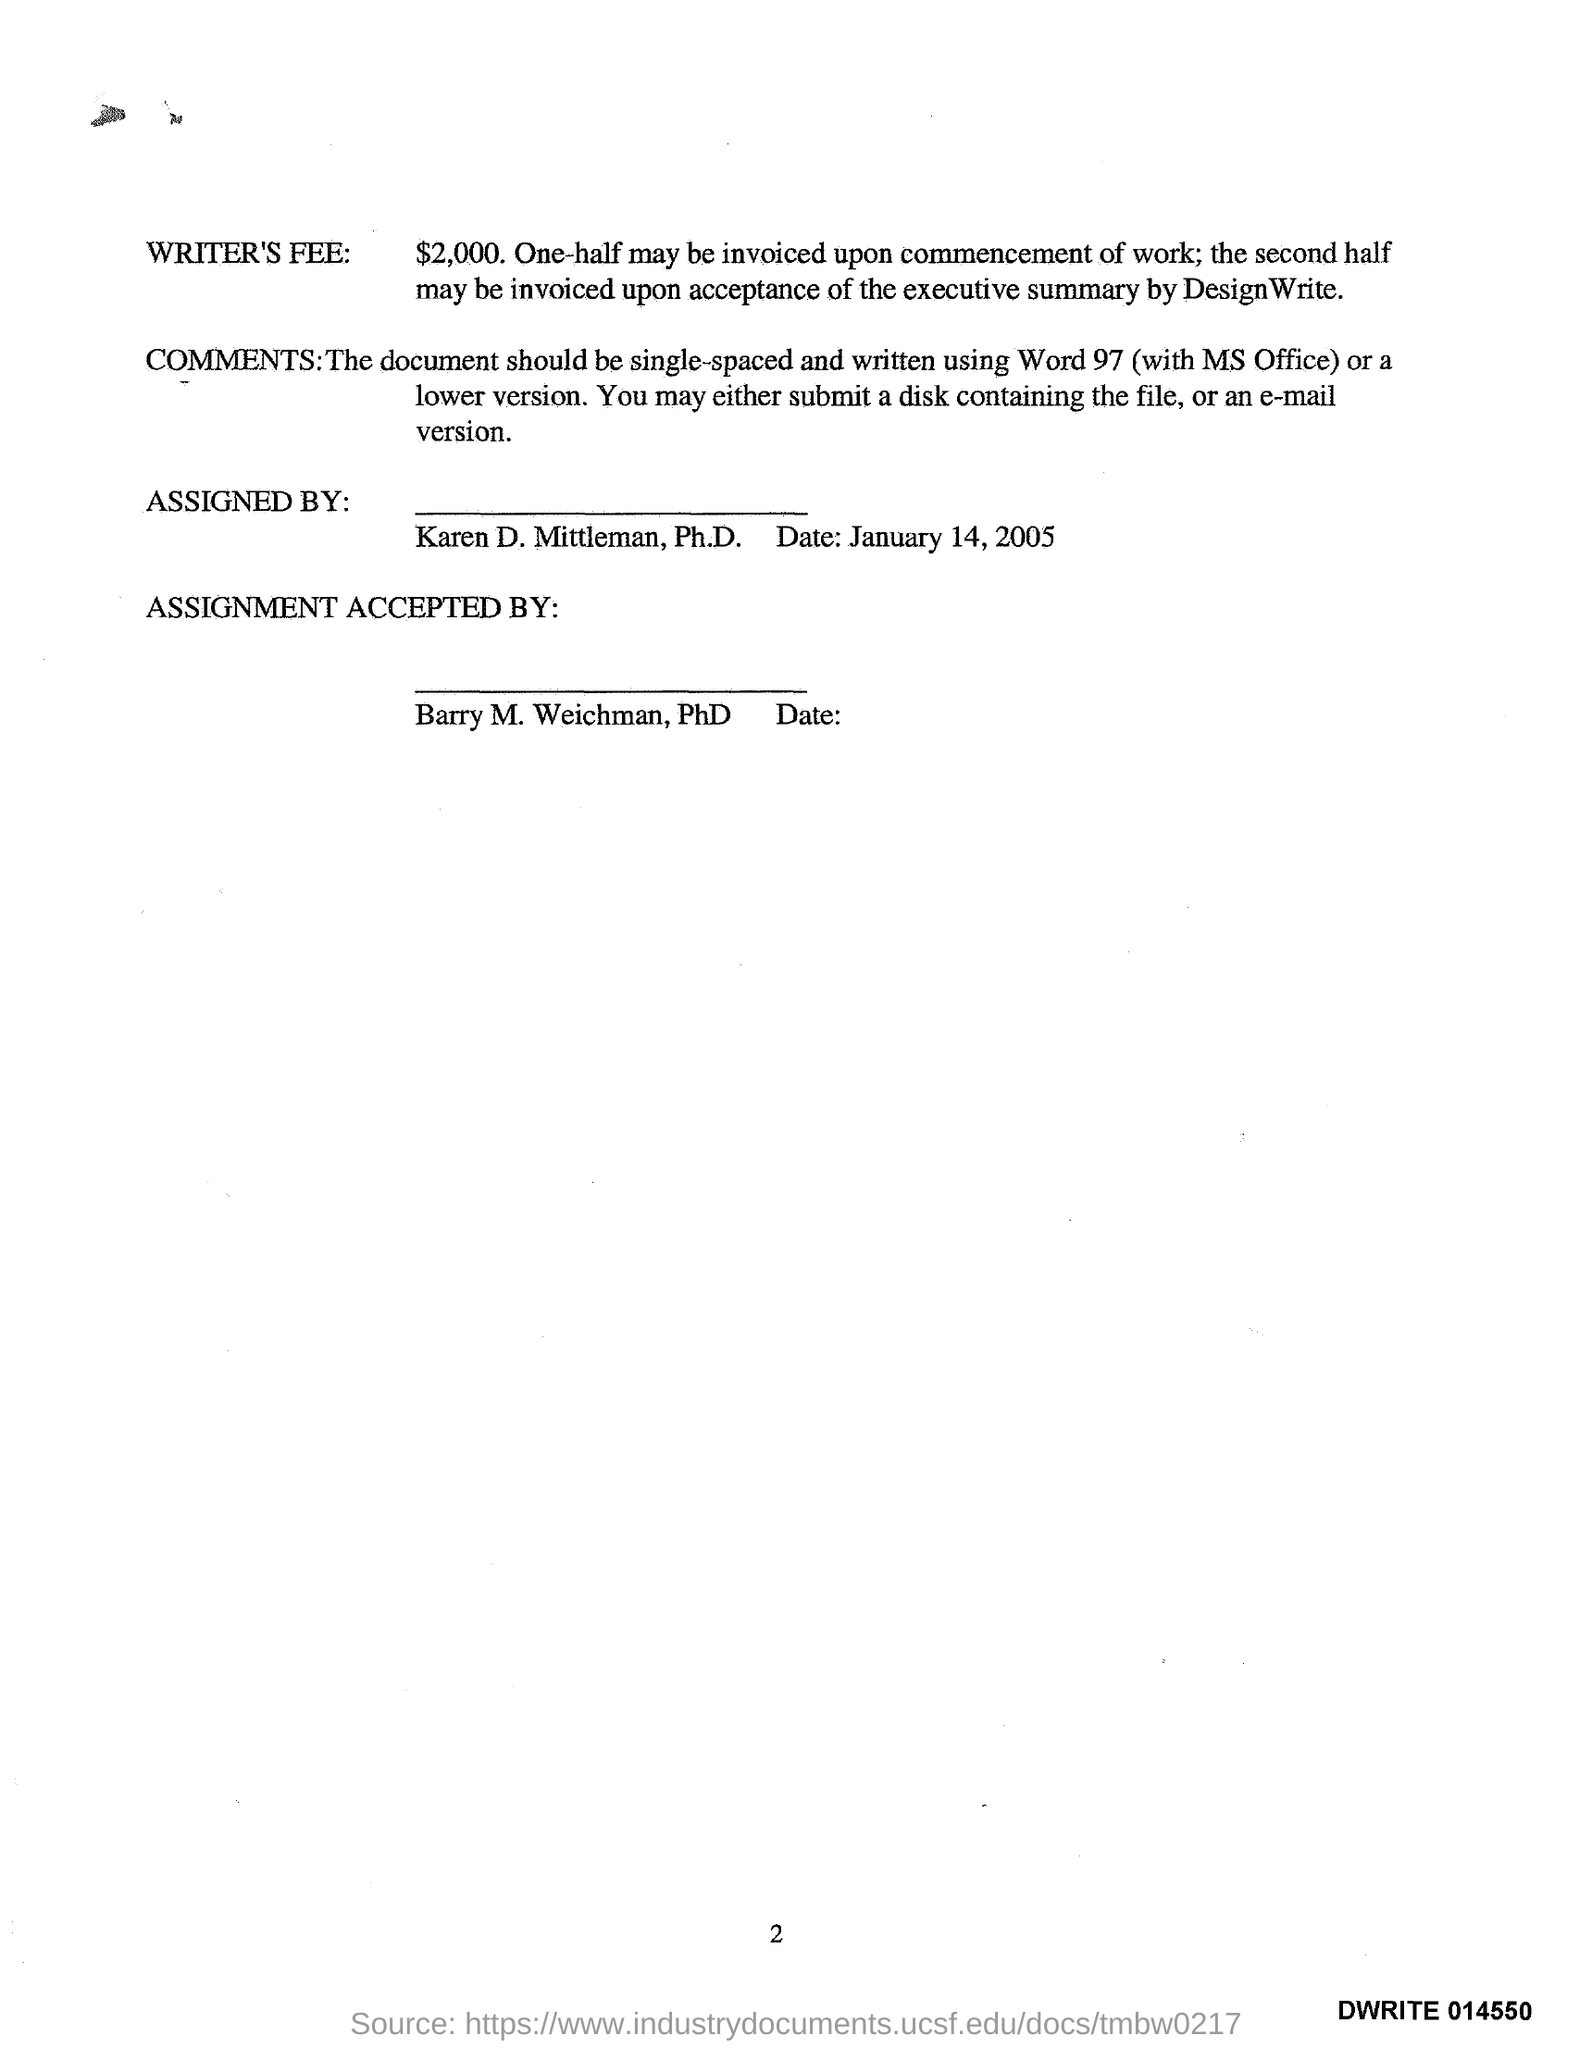Outline some significant characteristics in this image. The date mentioned is January 14, 2005. The amount of the WRITER'S FEE is $2,000. 